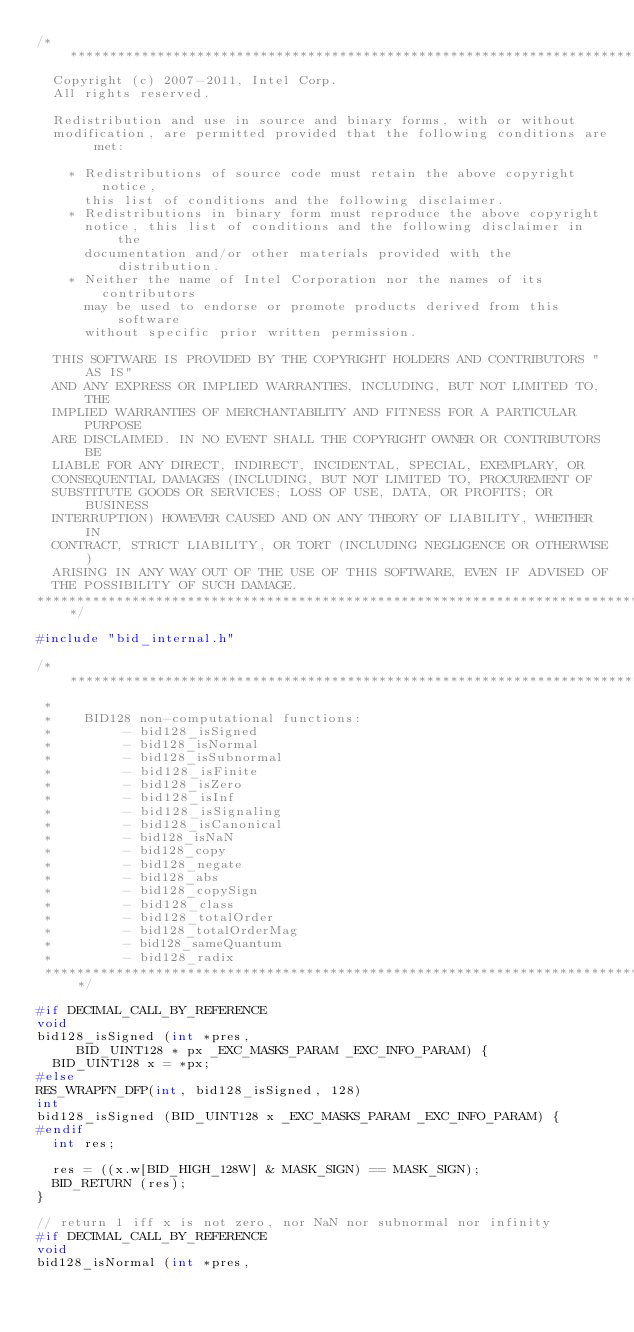Convert code to text. <code><loc_0><loc_0><loc_500><loc_500><_C_>/******************************************************************************
  Copyright (c) 2007-2011, Intel Corp.
  All rights reserved.

  Redistribution and use in source and binary forms, with or without 
  modification, are permitted provided that the following conditions are met:

    * Redistributions of source code must retain the above copyright notice, 
      this list of conditions and the following disclaimer.
    * Redistributions in binary form must reproduce the above copyright 
      notice, this list of conditions and the following disclaimer in the 
      documentation and/or other materials provided with the distribution.
    * Neither the name of Intel Corporation nor the names of its contributors 
      may be used to endorse or promote products derived from this software 
      without specific prior written permission.

  THIS SOFTWARE IS PROVIDED BY THE COPYRIGHT HOLDERS AND CONTRIBUTORS "AS IS"
  AND ANY EXPRESS OR IMPLIED WARRANTIES, INCLUDING, BUT NOT LIMITED TO, THE
  IMPLIED WARRANTIES OF MERCHANTABILITY AND FITNESS FOR A PARTICULAR PURPOSE
  ARE DISCLAIMED. IN NO EVENT SHALL THE COPYRIGHT OWNER OR CONTRIBUTORS BE
  LIABLE FOR ANY DIRECT, INDIRECT, INCIDENTAL, SPECIAL, EXEMPLARY, OR
  CONSEQUENTIAL DAMAGES (INCLUDING, BUT NOT LIMITED TO, PROCUREMENT OF
  SUBSTITUTE GOODS OR SERVICES; LOSS OF USE, DATA, OR PROFITS; OR BUSINESS
  INTERRUPTION) HOWEVER CAUSED AND ON ANY THEORY OF LIABILITY, WHETHER IN
  CONTRACT, STRICT LIABILITY, OR TORT (INCLUDING NEGLIGENCE OR OTHERWISE)
  ARISING IN ANY WAY OUT OF THE USE OF THIS SOFTWARE, EVEN IF ADVISED OF
  THE POSSIBILITY OF SUCH DAMAGE.
******************************************************************************/

#include "bid_internal.h"

/*****************************************************************************
 *
 *    BID128 non-computational functions:
 *         - bid128_isSigned
 *         - bid128_isNormal
 *         - bid128_isSubnormal
 *         - bid128_isFinite
 *         - bid128_isZero
 *         - bid128_isInf
 *         - bid128_isSignaling
 *         - bid128_isCanonical
 *         - bid128_isNaN
 *         - bid128_copy
 *         - bid128_negate
 *         - bid128_abs
 *         - bid128_copySign
 *         - bid128_class
 *         - bid128_totalOrder
 *         - bid128_totalOrderMag
 *         - bid128_sameQuantum
 *         - bid128_radix
 ****************************************************************************/

#if DECIMAL_CALL_BY_REFERENCE
void
bid128_isSigned (int *pres,
		 BID_UINT128 * px _EXC_MASKS_PARAM _EXC_INFO_PARAM) {
  BID_UINT128 x = *px;
#else
RES_WRAPFN_DFP(int, bid128_isSigned, 128)
int
bid128_isSigned (BID_UINT128 x _EXC_MASKS_PARAM _EXC_INFO_PARAM) {
#endif
  int res;

  res = ((x.w[BID_HIGH_128W] & MASK_SIGN) == MASK_SIGN);
  BID_RETURN (res);
}

// return 1 iff x is not zero, nor NaN nor subnormal nor infinity
#if DECIMAL_CALL_BY_REFERENCE
void
bid128_isNormal (int *pres,</code> 